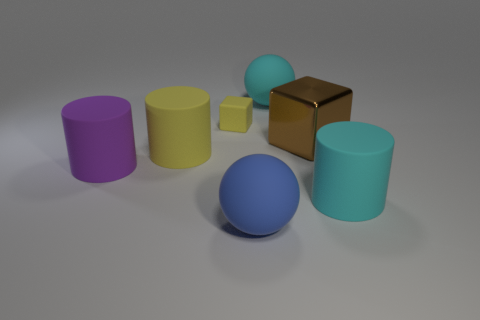Add 1 metal blocks. How many objects exist? 8 Subtract all brown blocks. Subtract all gray cylinders. How many blocks are left? 1 Subtract all cubes. How many objects are left? 5 Add 6 cylinders. How many cylinders are left? 9 Add 6 large yellow matte things. How many large yellow matte things exist? 7 Subtract 0 yellow spheres. How many objects are left? 7 Subtract all yellow cubes. Subtract all large yellow cylinders. How many objects are left? 5 